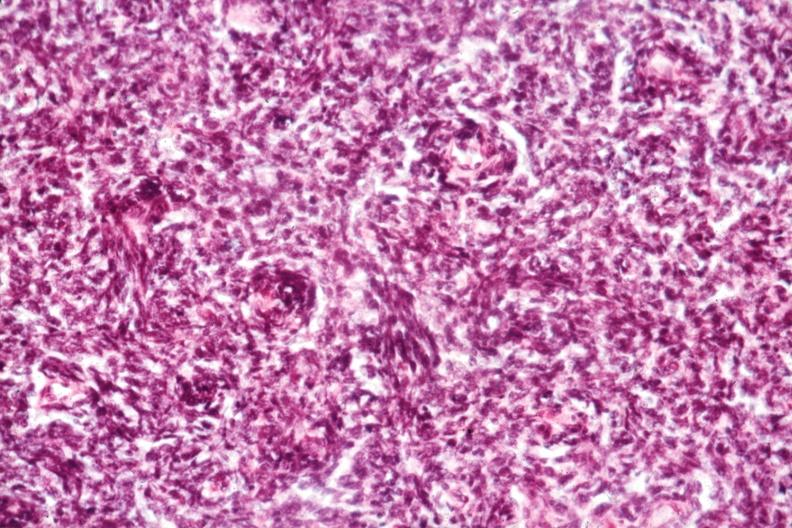s thymus present?
Answer the question using a single word or phrase. Yes 